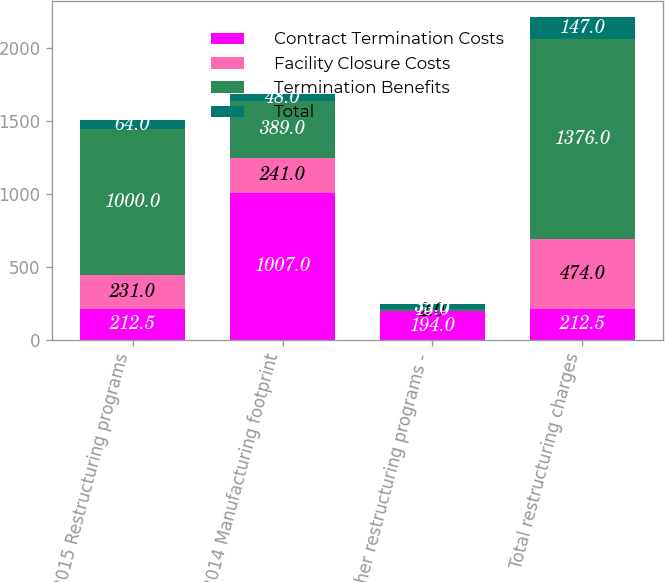<chart> <loc_0><loc_0><loc_500><loc_500><stacked_bar_chart><ecel><fcel>2015 Restructuring programs<fcel>2014 Manufacturing footprint<fcel>Other restructuring programs -<fcel>Total restructuring charges<nl><fcel>Contract Termination Costs<fcel>212.5<fcel>1007<fcel>194<fcel>212.5<nl><fcel>Facility Closure Costs<fcel>231<fcel>241<fcel>2<fcel>474<nl><fcel>Termination Benefits<fcel>1000<fcel>389<fcel>13<fcel>1376<nl><fcel>Total<fcel>64<fcel>48<fcel>35<fcel>147<nl></chart> 